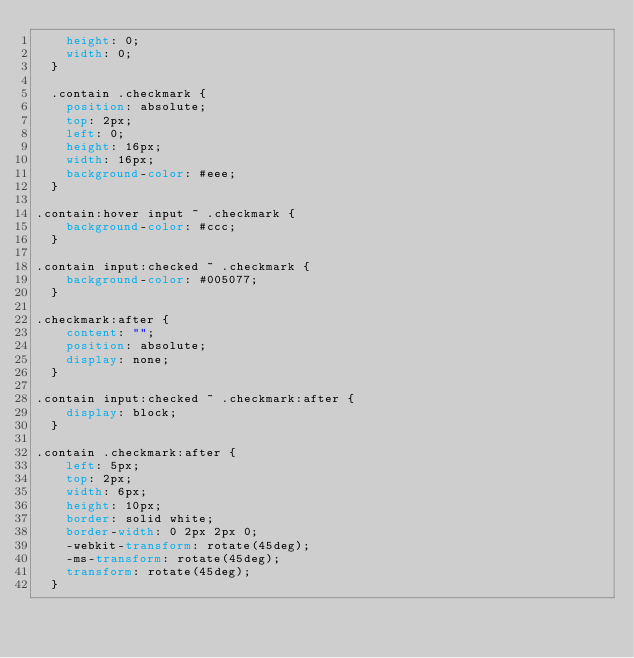Convert code to text. <code><loc_0><loc_0><loc_500><loc_500><_CSS_>    height: 0;
    width: 0;
  }

  .contain .checkmark {
    position: absolute;
    top: 2px;
    left: 0;
    height: 16px;
    width: 16px;
    background-color: #eee;
  }

.contain:hover input ~ .checkmark {
    background-color: #ccc;
  }

.contain input:checked ~ .checkmark {
    background-color: #005077;
  }

.checkmark:after {
    content: "";
    position: absolute;
    display: none;
  }

.contain input:checked ~ .checkmark:after {
    display: block;
  }

.contain .checkmark:after {
    left: 5px;
    top: 2px;
    width: 6px;
    height: 10px;
    border: solid white;
    border-width: 0 2px 2px 0;
    -webkit-transform: rotate(45deg);
    -ms-transform: rotate(45deg);
    transform: rotate(45deg);
  }</code> 